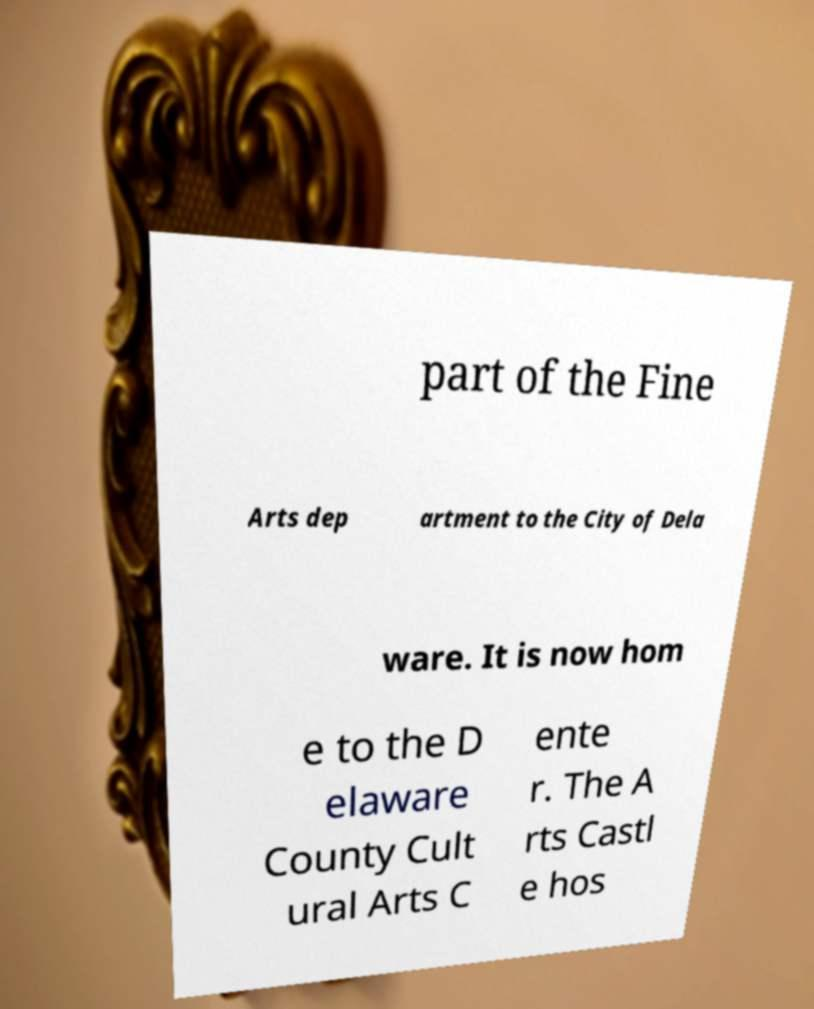Please read and relay the text visible in this image. What does it say? part of the Fine Arts dep artment to the City of Dela ware. It is now hom e to the D elaware County Cult ural Arts C ente r. The A rts Castl e hos 